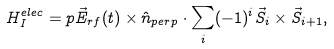Convert formula to latex. <formula><loc_0><loc_0><loc_500><loc_500>H ^ { e l e c } _ { I } = p \vec { E } _ { r f } ( t ) \times \hat { n } _ { p e r p } \cdot \sum _ { i } ( - 1 ) ^ { i } \vec { S } _ { i } \times \vec { S } _ { i + 1 } ,</formula> 